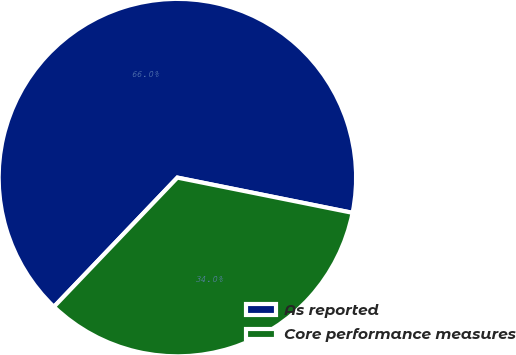Convert chart to OTSL. <chart><loc_0><loc_0><loc_500><loc_500><pie_chart><fcel>As reported<fcel>Core performance measures<nl><fcel>66.02%<fcel>33.98%<nl></chart> 